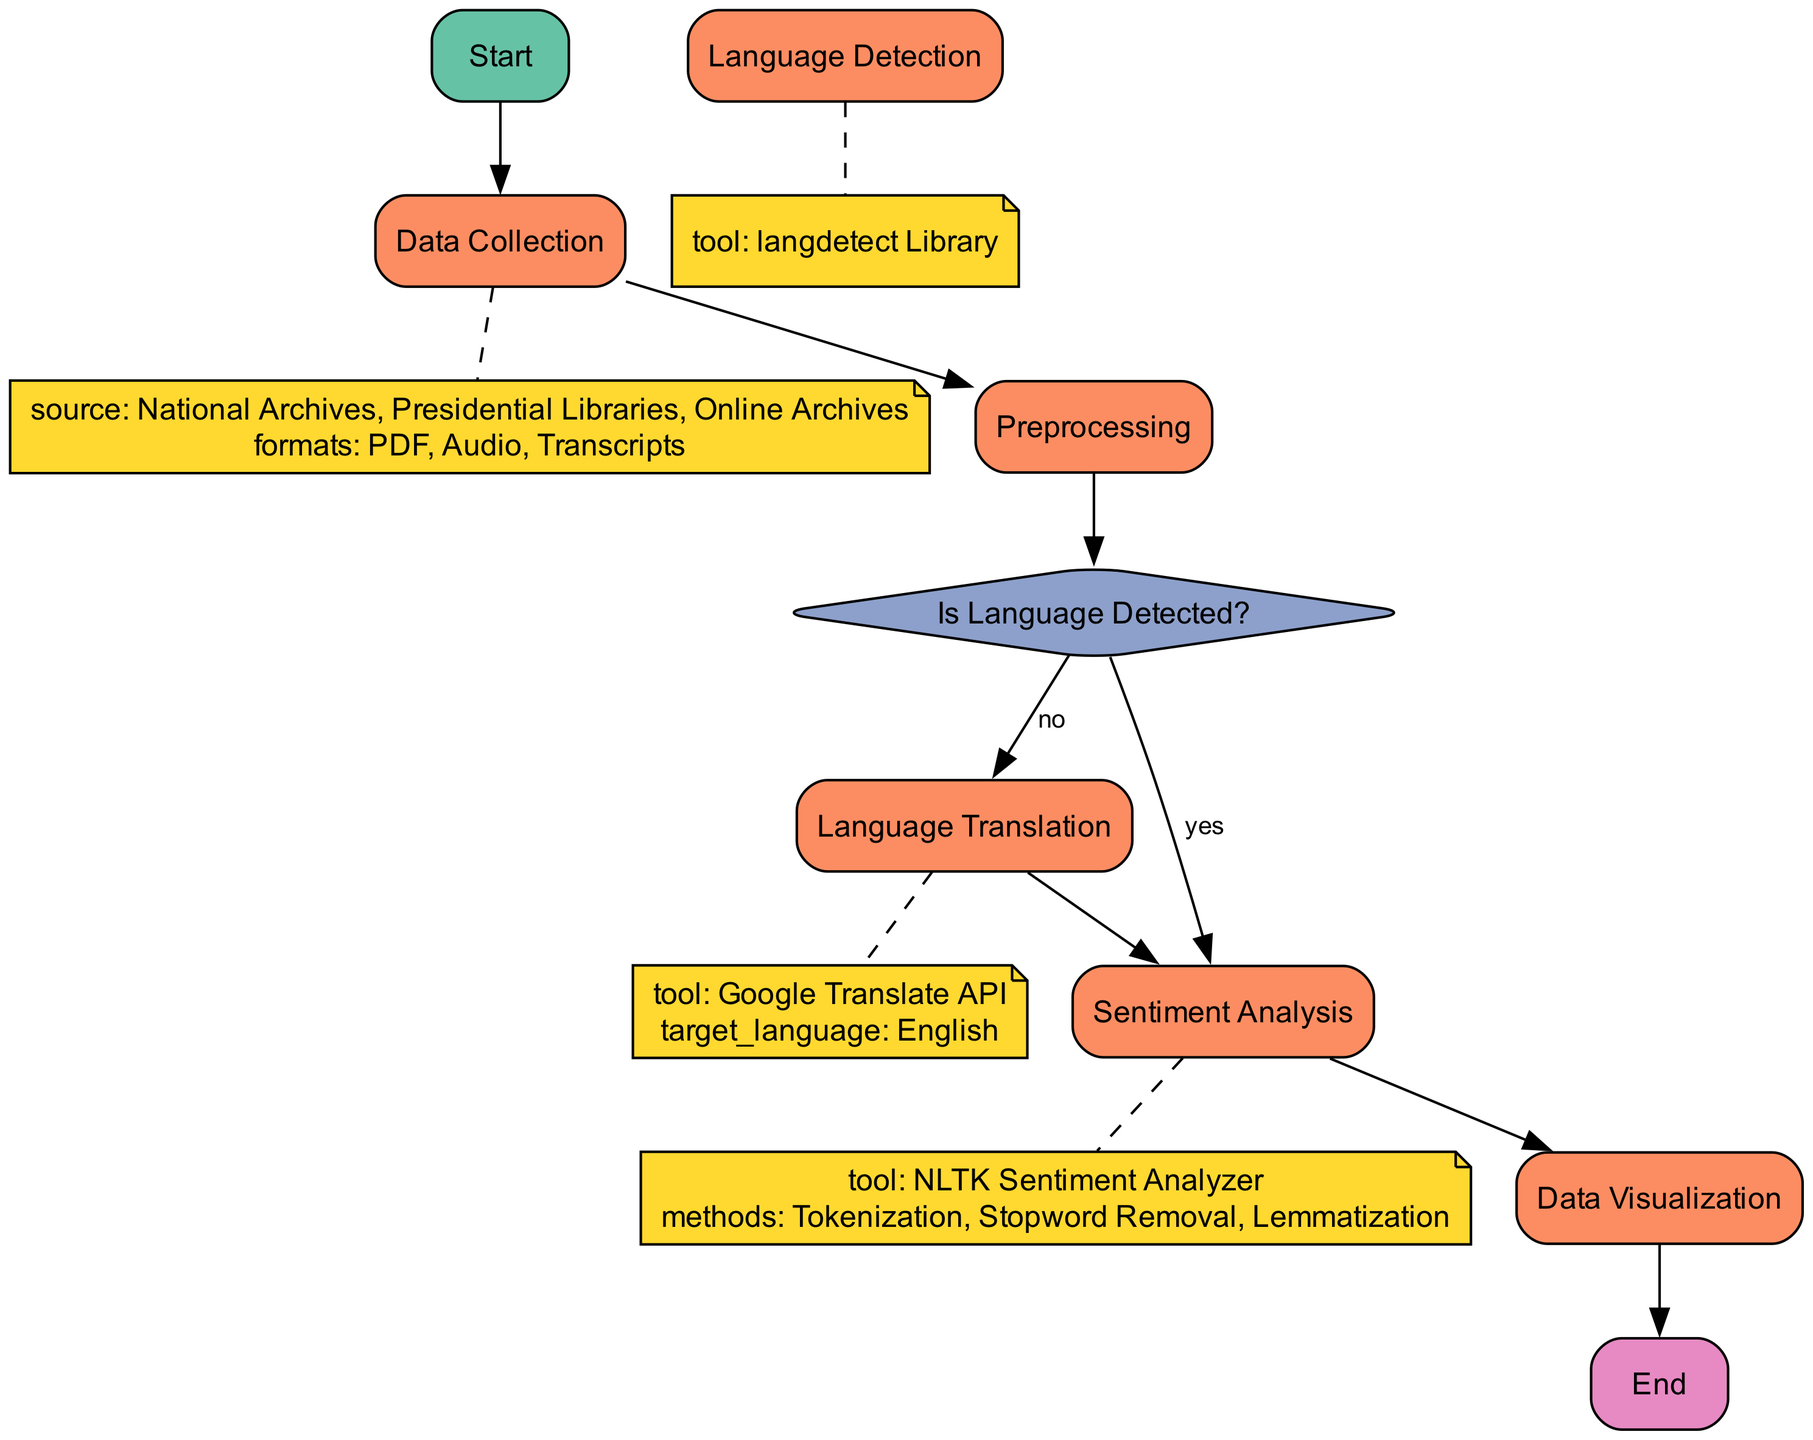What is the starting point of the pipeline? The starting point of the pipeline is labeled "Start." It serves as the initial entry point for the process flow in the diagram.
Answer: Start How many process nodes are in the diagram? By counting the process nodes (Data Collection, Preprocessing, Language Translation, Sentiment Analysis, Data Visualization), we find there are five process nodes in the diagram.
Answer: 5 In which step is language detected? The language is detected in the decision node labeled "Is Language Detected?" When the detection takes place, the flow diverges based on the outcome (Yes or No).
Answer: Is Language Detected? Which tool is used for sentiment analysis? The sentiment analysis process utilizes the "NLTK Sentiment Analyzer" tool according to the diagram specifics.
Answer: NLTK Sentiment Analyzer If the language is detected, which process follows? If the answer to the language detection question is "yes," the next process is "Sentiment Analysis," as indicated in the connection from the decision node to the process node.
Answer: Sentiment Analysis What follows after data visualization? After the "Data Visualization" process is complete, the flow ends at the "End" node, marking the conclusion of the pipeline process.
Answer: End What is the first step in data preprocessing? The initial step in the "Preprocessing" phase is "Optical Character Recognition (OCR) for PDFs," which is specifically mentioned as the primary task.
Answer: Optical Character Recognition (OCR) for PDFs What happens if no language is detected? If no language is detected (as indicated by the "no" pathway), the process moves to "Language Detection," where the langdetect Library is used to identify the language of the text.
Answer: Language Detection What type of diagram is this? This diagram is a flowchart, specifically designed to outline the steps and decisions involved in building a sentiment analysis pipeline.
Answer: Flowchart 